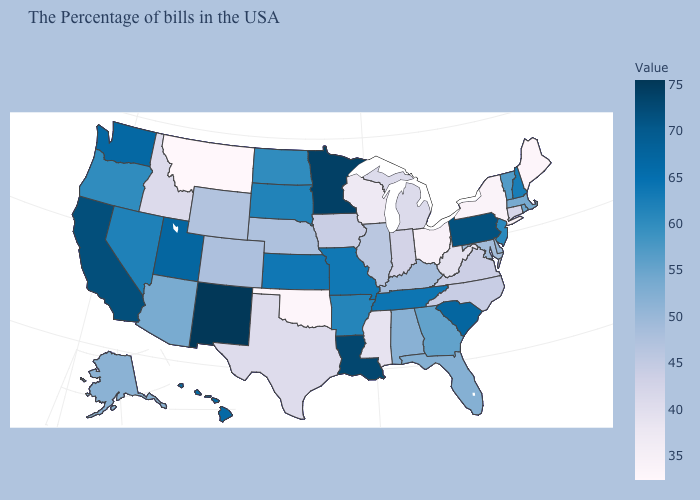Among the states that border Idaho , does Montana have the lowest value?
Keep it brief. Yes. Does the map have missing data?
Answer briefly. No. 